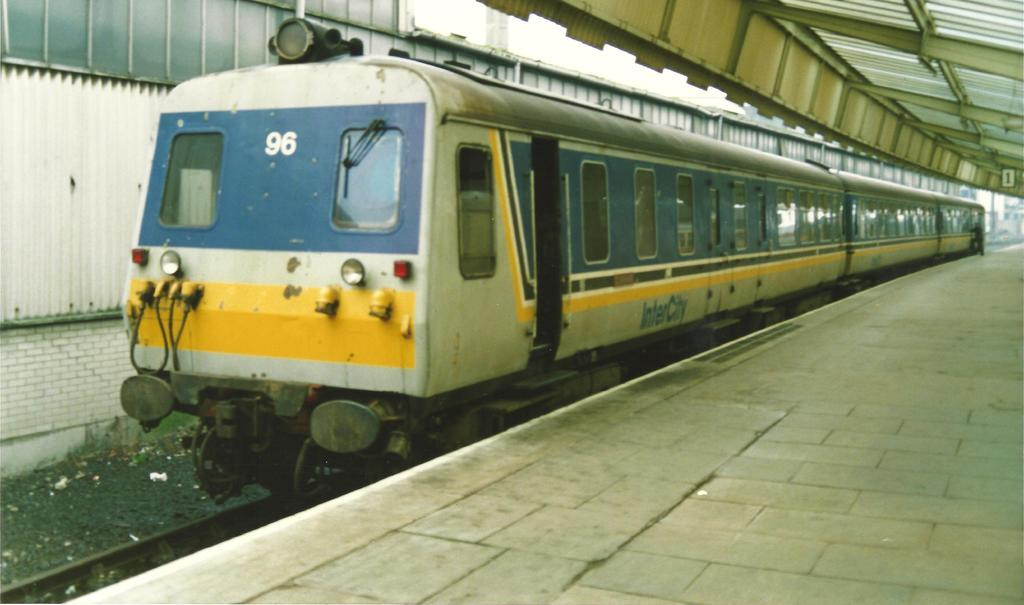What is the main subject of the image? The main subject of the image is a train. Where is the train located in the image? The train is on a railway track. What is present beside the train in the image? There is a railway platform beside the train. Can you see the parent rabbit lifting their child rabbit onto the train in the image? There is no rabbit or any indication of a parent lifting a child in the image. The image only features a train on a railway track with a railway platform beside it. 